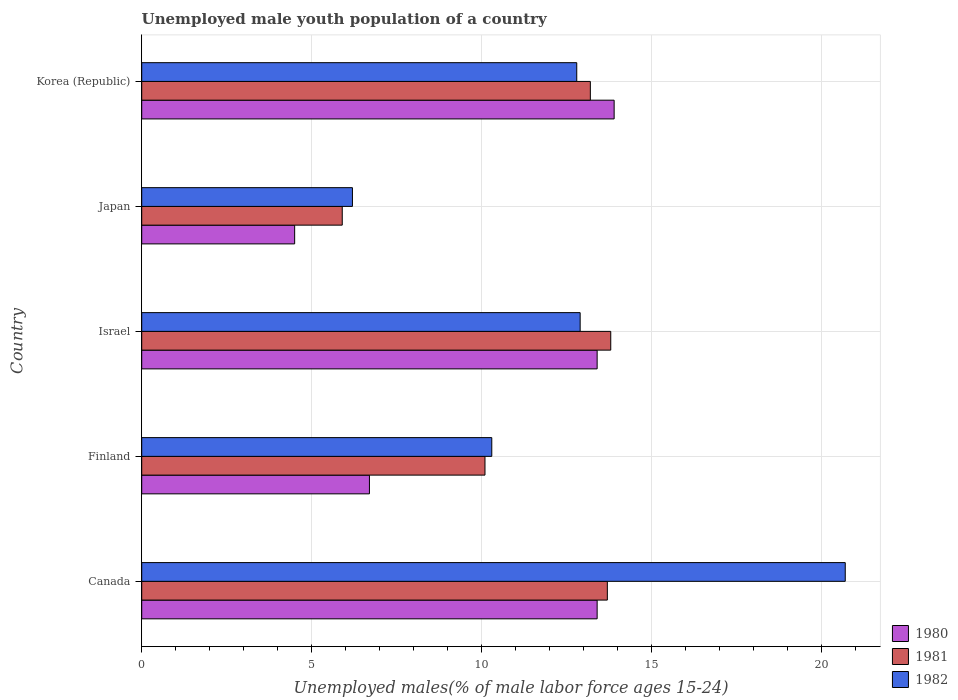Are the number of bars per tick equal to the number of legend labels?
Your response must be concise. Yes. What is the percentage of unemployed male youth population in 1982 in Finland?
Offer a very short reply. 10.3. Across all countries, what is the maximum percentage of unemployed male youth population in 1981?
Give a very brief answer. 13.8. Across all countries, what is the minimum percentage of unemployed male youth population in 1981?
Provide a succinct answer. 5.9. In which country was the percentage of unemployed male youth population in 1981 maximum?
Provide a short and direct response. Israel. In which country was the percentage of unemployed male youth population in 1982 minimum?
Your answer should be very brief. Japan. What is the total percentage of unemployed male youth population in 1980 in the graph?
Give a very brief answer. 51.9. What is the difference between the percentage of unemployed male youth population in 1981 in Finland and that in Korea (Republic)?
Keep it short and to the point. -3.1. What is the difference between the percentage of unemployed male youth population in 1980 in Israel and the percentage of unemployed male youth population in 1981 in Finland?
Ensure brevity in your answer.  3.3. What is the average percentage of unemployed male youth population in 1980 per country?
Your answer should be very brief. 10.38. What is the difference between the percentage of unemployed male youth population in 1982 and percentage of unemployed male youth population in 1980 in Japan?
Your answer should be very brief. 1.7. In how many countries, is the percentage of unemployed male youth population in 1980 greater than 5 %?
Keep it short and to the point. 4. What is the ratio of the percentage of unemployed male youth population in 1982 in Canada to that in Israel?
Provide a succinct answer. 1.6. What is the difference between the highest and the second highest percentage of unemployed male youth population in 1981?
Offer a terse response. 0.1. What is the difference between the highest and the lowest percentage of unemployed male youth population in 1981?
Your response must be concise. 7.9. In how many countries, is the percentage of unemployed male youth population in 1982 greater than the average percentage of unemployed male youth population in 1982 taken over all countries?
Provide a succinct answer. 3. Is the sum of the percentage of unemployed male youth population in 1981 in Finland and Korea (Republic) greater than the maximum percentage of unemployed male youth population in 1982 across all countries?
Your answer should be very brief. Yes. What does the 2nd bar from the top in Canada represents?
Ensure brevity in your answer.  1981. Are all the bars in the graph horizontal?
Offer a very short reply. Yes. How many countries are there in the graph?
Offer a terse response. 5. Are the values on the major ticks of X-axis written in scientific E-notation?
Make the answer very short. No. Does the graph contain any zero values?
Offer a very short reply. No. Where does the legend appear in the graph?
Your answer should be compact. Bottom right. How are the legend labels stacked?
Provide a succinct answer. Vertical. What is the title of the graph?
Your response must be concise. Unemployed male youth population of a country. Does "1991" appear as one of the legend labels in the graph?
Offer a terse response. No. What is the label or title of the X-axis?
Provide a short and direct response. Unemployed males(% of male labor force ages 15-24). What is the label or title of the Y-axis?
Keep it short and to the point. Country. What is the Unemployed males(% of male labor force ages 15-24) in 1980 in Canada?
Keep it short and to the point. 13.4. What is the Unemployed males(% of male labor force ages 15-24) of 1981 in Canada?
Offer a very short reply. 13.7. What is the Unemployed males(% of male labor force ages 15-24) of 1982 in Canada?
Provide a succinct answer. 20.7. What is the Unemployed males(% of male labor force ages 15-24) in 1980 in Finland?
Offer a terse response. 6.7. What is the Unemployed males(% of male labor force ages 15-24) of 1981 in Finland?
Ensure brevity in your answer.  10.1. What is the Unemployed males(% of male labor force ages 15-24) of 1982 in Finland?
Offer a very short reply. 10.3. What is the Unemployed males(% of male labor force ages 15-24) of 1980 in Israel?
Offer a very short reply. 13.4. What is the Unemployed males(% of male labor force ages 15-24) of 1981 in Israel?
Give a very brief answer. 13.8. What is the Unemployed males(% of male labor force ages 15-24) of 1982 in Israel?
Your response must be concise. 12.9. What is the Unemployed males(% of male labor force ages 15-24) of 1981 in Japan?
Keep it short and to the point. 5.9. What is the Unemployed males(% of male labor force ages 15-24) of 1982 in Japan?
Offer a terse response. 6.2. What is the Unemployed males(% of male labor force ages 15-24) in 1980 in Korea (Republic)?
Your response must be concise. 13.9. What is the Unemployed males(% of male labor force ages 15-24) of 1981 in Korea (Republic)?
Offer a very short reply. 13.2. What is the Unemployed males(% of male labor force ages 15-24) in 1982 in Korea (Republic)?
Keep it short and to the point. 12.8. Across all countries, what is the maximum Unemployed males(% of male labor force ages 15-24) of 1980?
Keep it short and to the point. 13.9. Across all countries, what is the maximum Unemployed males(% of male labor force ages 15-24) of 1981?
Your answer should be very brief. 13.8. Across all countries, what is the maximum Unemployed males(% of male labor force ages 15-24) in 1982?
Your answer should be compact. 20.7. Across all countries, what is the minimum Unemployed males(% of male labor force ages 15-24) of 1980?
Make the answer very short. 4.5. Across all countries, what is the minimum Unemployed males(% of male labor force ages 15-24) of 1981?
Offer a terse response. 5.9. Across all countries, what is the minimum Unemployed males(% of male labor force ages 15-24) of 1982?
Make the answer very short. 6.2. What is the total Unemployed males(% of male labor force ages 15-24) of 1980 in the graph?
Give a very brief answer. 51.9. What is the total Unemployed males(% of male labor force ages 15-24) of 1981 in the graph?
Keep it short and to the point. 56.7. What is the total Unemployed males(% of male labor force ages 15-24) of 1982 in the graph?
Your answer should be very brief. 62.9. What is the difference between the Unemployed males(% of male labor force ages 15-24) in 1981 in Canada and that in Finland?
Give a very brief answer. 3.6. What is the difference between the Unemployed males(% of male labor force ages 15-24) of 1981 in Canada and that in Israel?
Offer a very short reply. -0.1. What is the difference between the Unemployed males(% of male labor force ages 15-24) of 1982 in Canada and that in Israel?
Keep it short and to the point. 7.8. What is the difference between the Unemployed males(% of male labor force ages 15-24) in 1980 in Canada and that in Japan?
Make the answer very short. 8.9. What is the difference between the Unemployed males(% of male labor force ages 15-24) of 1981 in Canada and that in Japan?
Give a very brief answer. 7.8. What is the difference between the Unemployed males(% of male labor force ages 15-24) of 1982 in Canada and that in Japan?
Make the answer very short. 14.5. What is the difference between the Unemployed males(% of male labor force ages 15-24) of 1980 in Canada and that in Korea (Republic)?
Ensure brevity in your answer.  -0.5. What is the difference between the Unemployed males(% of male labor force ages 15-24) in 1981 in Finland and that in Israel?
Make the answer very short. -3.7. What is the difference between the Unemployed males(% of male labor force ages 15-24) of 1980 in Finland and that in Japan?
Your answer should be compact. 2.2. What is the difference between the Unemployed males(% of male labor force ages 15-24) in 1981 in Finland and that in Japan?
Your answer should be very brief. 4.2. What is the difference between the Unemployed males(% of male labor force ages 15-24) in 1980 in Finland and that in Korea (Republic)?
Your answer should be very brief. -7.2. What is the difference between the Unemployed males(% of male labor force ages 15-24) of 1980 in Israel and that in Japan?
Give a very brief answer. 8.9. What is the difference between the Unemployed males(% of male labor force ages 15-24) in 1980 in Israel and that in Korea (Republic)?
Provide a short and direct response. -0.5. What is the difference between the Unemployed males(% of male labor force ages 15-24) of 1982 in Israel and that in Korea (Republic)?
Make the answer very short. 0.1. What is the difference between the Unemployed males(% of male labor force ages 15-24) in 1980 in Japan and that in Korea (Republic)?
Provide a short and direct response. -9.4. What is the difference between the Unemployed males(% of male labor force ages 15-24) in 1981 in Japan and that in Korea (Republic)?
Provide a succinct answer. -7.3. What is the difference between the Unemployed males(% of male labor force ages 15-24) in 1980 in Canada and the Unemployed males(% of male labor force ages 15-24) in 1981 in Finland?
Provide a succinct answer. 3.3. What is the difference between the Unemployed males(% of male labor force ages 15-24) in 1980 in Canada and the Unemployed males(% of male labor force ages 15-24) in 1982 in Finland?
Offer a very short reply. 3.1. What is the difference between the Unemployed males(% of male labor force ages 15-24) in 1980 in Canada and the Unemployed males(% of male labor force ages 15-24) in 1982 in Israel?
Your response must be concise. 0.5. What is the difference between the Unemployed males(% of male labor force ages 15-24) of 1980 in Canada and the Unemployed males(% of male labor force ages 15-24) of 1982 in Korea (Republic)?
Your answer should be compact. 0.6. What is the difference between the Unemployed males(% of male labor force ages 15-24) in 1980 in Finland and the Unemployed males(% of male labor force ages 15-24) in 1981 in Israel?
Offer a very short reply. -7.1. What is the difference between the Unemployed males(% of male labor force ages 15-24) in 1981 in Finland and the Unemployed males(% of male labor force ages 15-24) in 1982 in Japan?
Your answer should be compact. 3.9. What is the difference between the Unemployed males(% of male labor force ages 15-24) in 1980 in Finland and the Unemployed males(% of male labor force ages 15-24) in 1981 in Korea (Republic)?
Ensure brevity in your answer.  -6.5. What is the difference between the Unemployed males(% of male labor force ages 15-24) in 1981 in Finland and the Unemployed males(% of male labor force ages 15-24) in 1982 in Korea (Republic)?
Provide a succinct answer. -2.7. What is the difference between the Unemployed males(% of male labor force ages 15-24) of 1980 in Israel and the Unemployed males(% of male labor force ages 15-24) of 1982 in Japan?
Your answer should be compact. 7.2. What is the difference between the Unemployed males(% of male labor force ages 15-24) in 1980 in Japan and the Unemployed males(% of male labor force ages 15-24) in 1981 in Korea (Republic)?
Offer a very short reply. -8.7. What is the average Unemployed males(% of male labor force ages 15-24) of 1980 per country?
Make the answer very short. 10.38. What is the average Unemployed males(% of male labor force ages 15-24) of 1981 per country?
Offer a terse response. 11.34. What is the average Unemployed males(% of male labor force ages 15-24) of 1982 per country?
Give a very brief answer. 12.58. What is the difference between the Unemployed males(% of male labor force ages 15-24) in 1980 and Unemployed males(% of male labor force ages 15-24) in 1981 in Canada?
Offer a very short reply. -0.3. What is the difference between the Unemployed males(% of male labor force ages 15-24) in 1980 and Unemployed males(% of male labor force ages 15-24) in 1982 in Canada?
Make the answer very short. -7.3. What is the difference between the Unemployed males(% of male labor force ages 15-24) of 1980 and Unemployed males(% of male labor force ages 15-24) of 1982 in Finland?
Your response must be concise. -3.6. What is the difference between the Unemployed males(% of male labor force ages 15-24) of 1980 and Unemployed males(% of male labor force ages 15-24) of 1981 in Israel?
Ensure brevity in your answer.  -0.4. What is the difference between the Unemployed males(% of male labor force ages 15-24) of 1981 and Unemployed males(% of male labor force ages 15-24) of 1982 in Korea (Republic)?
Your answer should be very brief. 0.4. What is the ratio of the Unemployed males(% of male labor force ages 15-24) in 1980 in Canada to that in Finland?
Offer a very short reply. 2. What is the ratio of the Unemployed males(% of male labor force ages 15-24) of 1981 in Canada to that in Finland?
Offer a terse response. 1.36. What is the ratio of the Unemployed males(% of male labor force ages 15-24) in 1982 in Canada to that in Finland?
Your answer should be very brief. 2.01. What is the ratio of the Unemployed males(% of male labor force ages 15-24) of 1982 in Canada to that in Israel?
Ensure brevity in your answer.  1.6. What is the ratio of the Unemployed males(% of male labor force ages 15-24) in 1980 in Canada to that in Japan?
Your answer should be very brief. 2.98. What is the ratio of the Unemployed males(% of male labor force ages 15-24) in 1981 in Canada to that in Japan?
Your response must be concise. 2.32. What is the ratio of the Unemployed males(% of male labor force ages 15-24) in 1982 in Canada to that in Japan?
Your answer should be very brief. 3.34. What is the ratio of the Unemployed males(% of male labor force ages 15-24) of 1980 in Canada to that in Korea (Republic)?
Make the answer very short. 0.96. What is the ratio of the Unemployed males(% of male labor force ages 15-24) in 1981 in Canada to that in Korea (Republic)?
Give a very brief answer. 1.04. What is the ratio of the Unemployed males(% of male labor force ages 15-24) in 1982 in Canada to that in Korea (Republic)?
Ensure brevity in your answer.  1.62. What is the ratio of the Unemployed males(% of male labor force ages 15-24) of 1980 in Finland to that in Israel?
Ensure brevity in your answer.  0.5. What is the ratio of the Unemployed males(% of male labor force ages 15-24) of 1981 in Finland to that in Israel?
Your response must be concise. 0.73. What is the ratio of the Unemployed males(% of male labor force ages 15-24) of 1982 in Finland to that in Israel?
Provide a succinct answer. 0.8. What is the ratio of the Unemployed males(% of male labor force ages 15-24) in 1980 in Finland to that in Japan?
Provide a short and direct response. 1.49. What is the ratio of the Unemployed males(% of male labor force ages 15-24) of 1981 in Finland to that in Japan?
Ensure brevity in your answer.  1.71. What is the ratio of the Unemployed males(% of male labor force ages 15-24) in 1982 in Finland to that in Japan?
Offer a terse response. 1.66. What is the ratio of the Unemployed males(% of male labor force ages 15-24) in 1980 in Finland to that in Korea (Republic)?
Offer a terse response. 0.48. What is the ratio of the Unemployed males(% of male labor force ages 15-24) of 1981 in Finland to that in Korea (Republic)?
Provide a succinct answer. 0.77. What is the ratio of the Unemployed males(% of male labor force ages 15-24) in 1982 in Finland to that in Korea (Republic)?
Make the answer very short. 0.8. What is the ratio of the Unemployed males(% of male labor force ages 15-24) in 1980 in Israel to that in Japan?
Your response must be concise. 2.98. What is the ratio of the Unemployed males(% of male labor force ages 15-24) in 1981 in Israel to that in Japan?
Offer a very short reply. 2.34. What is the ratio of the Unemployed males(% of male labor force ages 15-24) of 1982 in Israel to that in Japan?
Make the answer very short. 2.08. What is the ratio of the Unemployed males(% of male labor force ages 15-24) of 1981 in Israel to that in Korea (Republic)?
Provide a succinct answer. 1.05. What is the ratio of the Unemployed males(% of male labor force ages 15-24) in 1980 in Japan to that in Korea (Republic)?
Your answer should be very brief. 0.32. What is the ratio of the Unemployed males(% of male labor force ages 15-24) of 1981 in Japan to that in Korea (Republic)?
Keep it short and to the point. 0.45. What is the ratio of the Unemployed males(% of male labor force ages 15-24) in 1982 in Japan to that in Korea (Republic)?
Keep it short and to the point. 0.48. What is the difference between the highest and the lowest Unemployed males(% of male labor force ages 15-24) in 1980?
Keep it short and to the point. 9.4. What is the difference between the highest and the lowest Unemployed males(% of male labor force ages 15-24) in 1981?
Your answer should be very brief. 7.9. 